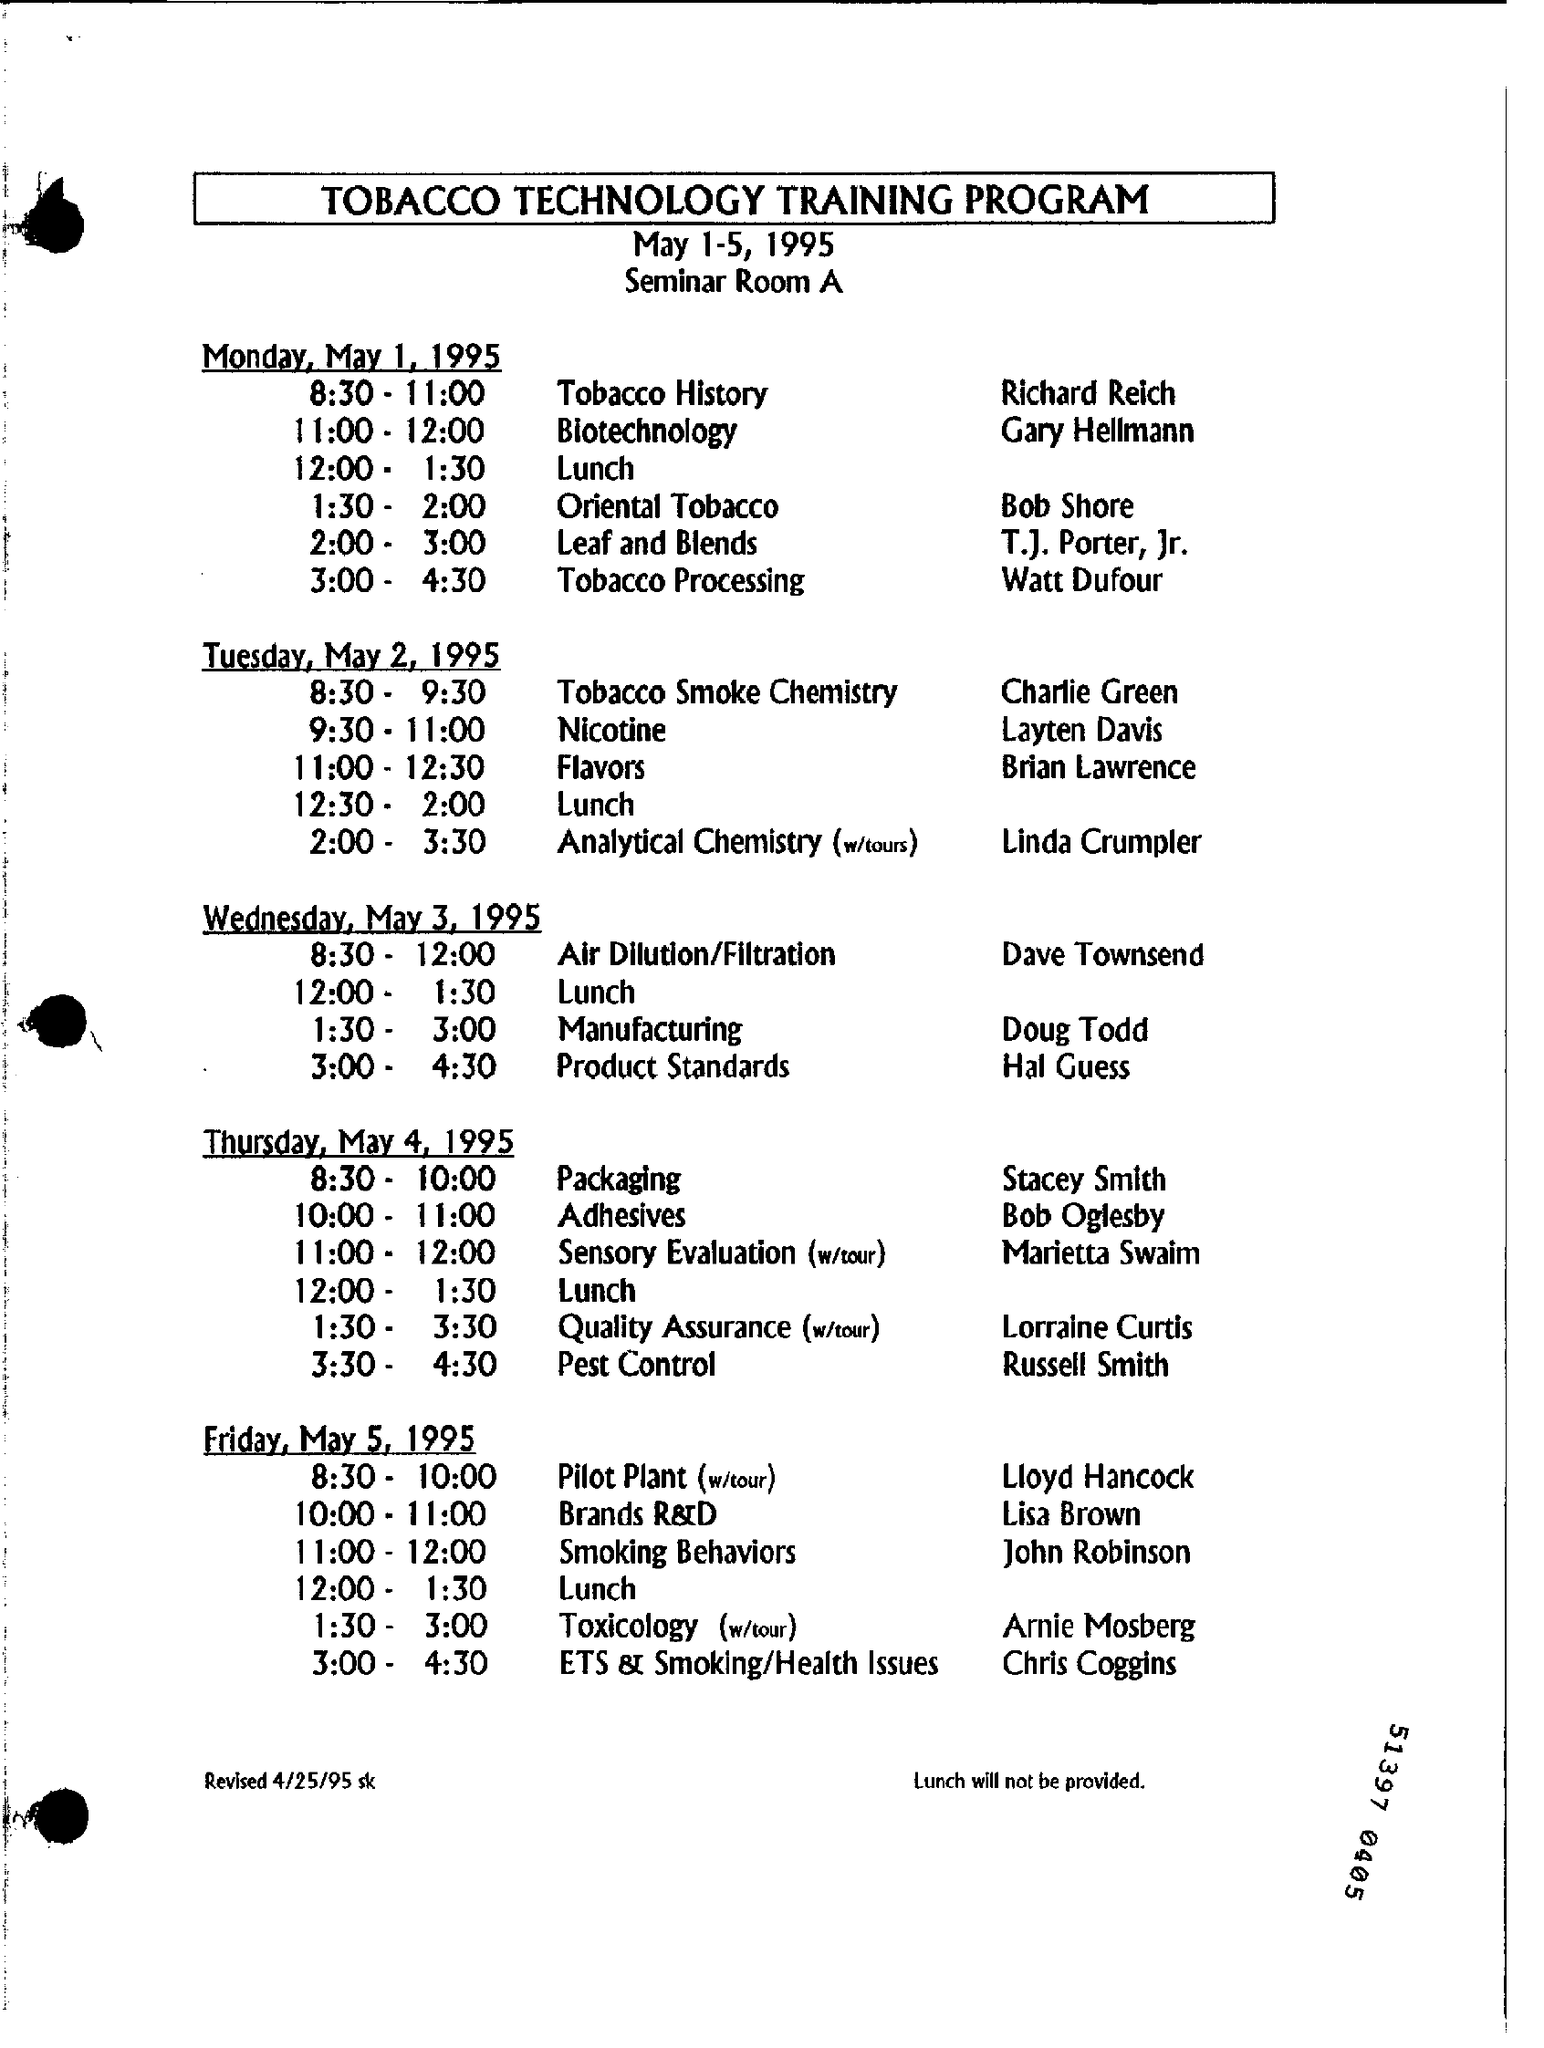What is the document title?
Your answer should be compact. TOBACCO TECHNOLOGY TRAINING PROGRAM. When is the program going to be held?
Provide a short and direct response. May 1-5, 1995. Where is the program going to be held?
Your answer should be very brief. Seminar Room A. Who will lead Tobacco Smoke Chemistry on Tuesday, May 2, 1995?
Give a very brief answer. Charlie Green. What is Doug Todd's topic for Wednesday?
Offer a very short reply. Manufacturing. When was the document revised?
Ensure brevity in your answer.  4/25/95. 